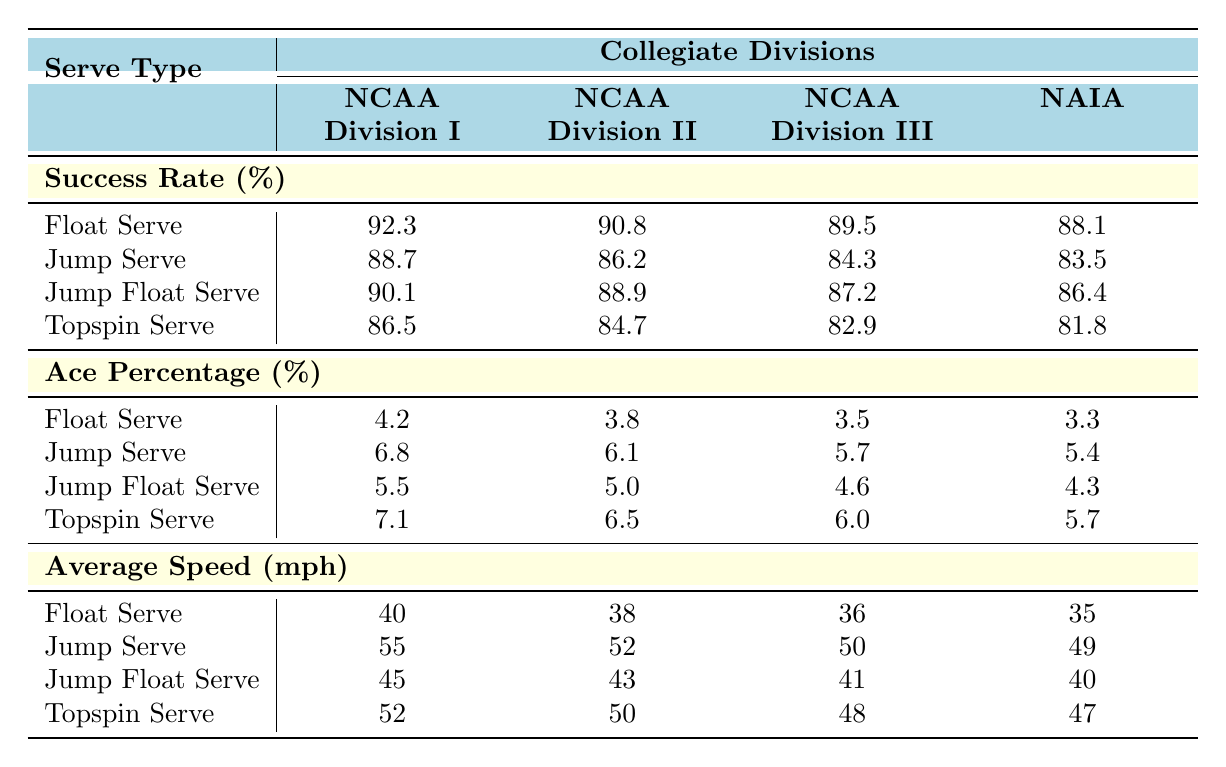What is the success rate of the Jump Serve in NCAA Division I? The table shows the success rate of the Jump Serve in NCAA Division I as 88.7%.
Answer: 88.7% Which serve type has the highest success rate in NCAA Division III? In NCAA Division III, the Float Serve has the highest success rate at 89.5%.
Answer: Float Serve True or False: The average speed of the Float Serve is higher in NCAA Division I than in NAIA. The average speed of the Float Serve in NCAA Division I is 40 mph, while in NAIA it is 35 mph, so the statement is true.
Answer: True What is the difference in ace percentage between the Jump Serve in NCAA Division I and NCAA Division II? The ace percentage for the Jump Serve in NCAA Division I is 6.8% and in NCAA Division II is 6.1%. The difference is 6.8% - 6.1% = 0.7%.
Answer: 0.7% Which collegiate division has the lowest ace percentage for the Topspin Serve? The NAIA has the lowest ace percentage for the Topspin Serve at 5.7%.
Answer: NAIA Calculate the average success rate for the Float Serve across all divisions. The success rates for the Float Serve are 92.3% (Division I), 90.8% (Division II), 89.5% (Division III), and 88.1% (NAIA). The sum is 92.3 + 90.8 + 89.5 + 88.1 = 360.7 and the average is 360.7 / 4 = 90.175%.
Answer: 90.175% What serve type has the highest average speed across all divisions? The Jump Serve has the highest average speed at 55 mph in NCAA Division I, which is higher than the average speeds of the jump serves in other divisions.
Answer: Jump Serve How does the ace percentage for the Jump Float Serve compare between NCAA Division II and NCAA Division III? The ace percentage for the Jump Float Serve in NCAA Division II is 5.0%, while in NCAA Division III it is 4.6%. This shows that NCAA Division II has a higher ace percentage.
Answer: NCAA Division II What is the average success rate for all serve types in NCAA Division II? The success rates for NCAA Division II are 90.8% (Float Serve), 86.2% (Jump Serve), 88.9% (Jump Float Serve), and 84.7% (Topspin Serve). The sum is 90.8 + 86.2 + 88.9 + 84.7 = 350.6 and the average is 350.6 / 4 = 87.65%.
Answer: 87.65% Is the average speed of the Jump Float Serve lower in NCAA Division III compared to NAIA? The average speed of the Jump Float Serve in NCAA Division III is 41 mph, and in NAIA, it is 40 mph. Therefore, the average speed of the Jump Float Serve is higher in NCAA Division III.
Answer: No 